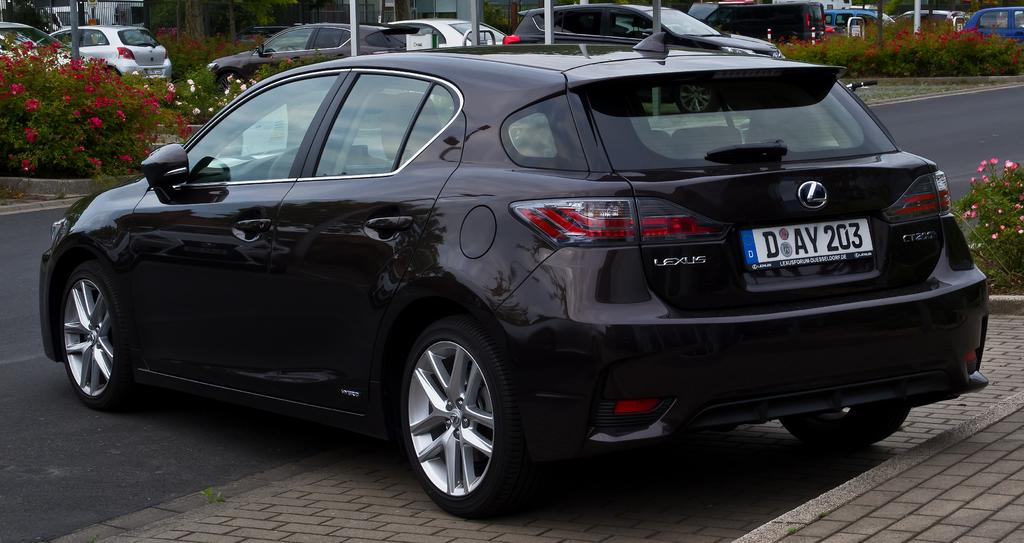What type of vehicles can be seen on the road in the image? There are cars on the road in the image. What can be seen in the background of the image? There are flower plants and poles in the background of the image. What is the color of the car in the front? The car in the front is black in color. Can you tell me how many buttons are on the flower plants in the image? There are no buttons present on the flower plants in the image; they are natural plants. 